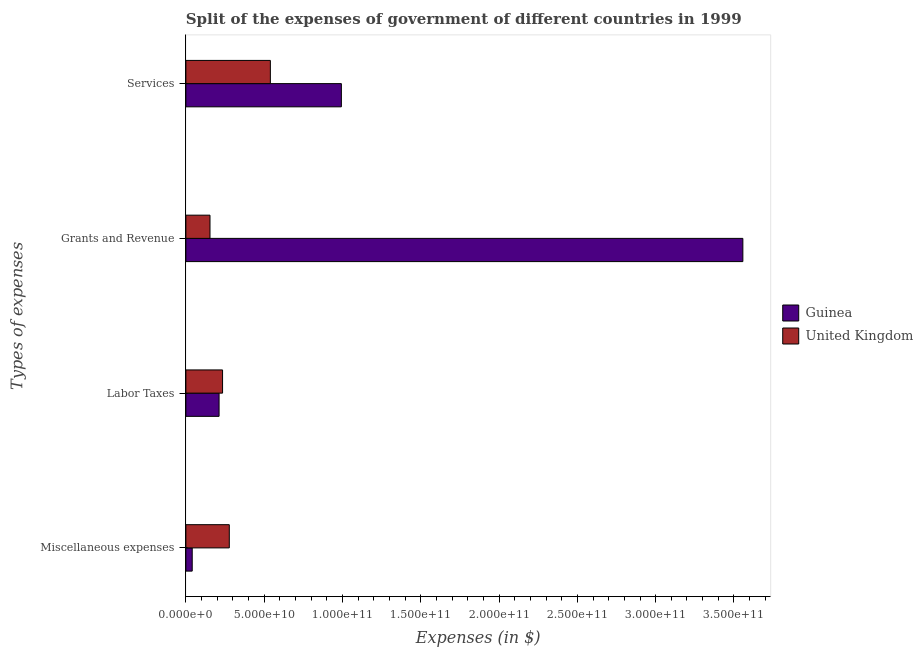How many different coloured bars are there?
Your answer should be very brief. 2. Are the number of bars on each tick of the Y-axis equal?
Your answer should be compact. Yes. How many bars are there on the 3rd tick from the top?
Give a very brief answer. 2. What is the label of the 3rd group of bars from the top?
Keep it short and to the point. Labor Taxes. What is the amount spent on services in United Kingdom?
Ensure brevity in your answer.  5.39e+1. Across all countries, what is the maximum amount spent on grants and revenue?
Keep it short and to the point. 3.56e+11. Across all countries, what is the minimum amount spent on labor taxes?
Your response must be concise. 2.12e+1. In which country was the amount spent on services maximum?
Provide a succinct answer. Guinea. What is the total amount spent on miscellaneous expenses in the graph?
Your response must be concise. 3.18e+1. What is the difference between the amount spent on services in United Kingdom and that in Guinea?
Your answer should be compact. -4.54e+1. What is the difference between the amount spent on labor taxes in United Kingdom and the amount spent on miscellaneous expenses in Guinea?
Offer a terse response. 1.94e+1. What is the average amount spent on miscellaneous expenses per country?
Provide a succinct answer. 1.59e+1. What is the difference between the amount spent on grants and revenue and amount spent on labor taxes in United Kingdom?
Offer a very short reply. -8.03e+09. What is the ratio of the amount spent on services in Guinea to that in United Kingdom?
Make the answer very short. 1.84. What is the difference between the highest and the second highest amount spent on grants and revenue?
Offer a terse response. 3.40e+11. What is the difference between the highest and the lowest amount spent on grants and revenue?
Ensure brevity in your answer.  3.40e+11. What does the 1st bar from the bottom in Grants and Revenue represents?
Give a very brief answer. Guinea. Is it the case that in every country, the sum of the amount spent on miscellaneous expenses and amount spent on labor taxes is greater than the amount spent on grants and revenue?
Your answer should be compact. No. How many bars are there?
Give a very brief answer. 8. What is the title of the graph?
Offer a very short reply. Split of the expenses of government of different countries in 1999. Does "Belgium" appear as one of the legend labels in the graph?
Your response must be concise. No. What is the label or title of the X-axis?
Keep it short and to the point. Expenses (in $). What is the label or title of the Y-axis?
Make the answer very short. Types of expenses. What is the Expenses (in $) in Guinea in Miscellaneous expenses?
Provide a short and direct response. 4.05e+09. What is the Expenses (in $) in United Kingdom in Miscellaneous expenses?
Make the answer very short. 2.77e+1. What is the Expenses (in $) of Guinea in Labor Taxes?
Offer a terse response. 2.12e+1. What is the Expenses (in $) of United Kingdom in Labor Taxes?
Ensure brevity in your answer.  2.34e+1. What is the Expenses (in $) in Guinea in Grants and Revenue?
Keep it short and to the point. 3.56e+11. What is the Expenses (in $) in United Kingdom in Grants and Revenue?
Your response must be concise. 1.54e+1. What is the Expenses (in $) in Guinea in Services?
Ensure brevity in your answer.  9.93e+1. What is the Expenses (in $) in United Kingdom in Services?
Ensure brevity in your answer.  5.39e+1. Across all Types of expenses, what is the maximum Expenses (in $) of Guinea?
Make the answer very short. 3.56e+11. Across all Types of expenses, what is the maximum Expenses (in $) of United Kingdom?
Ensure brevity in your answer.  5.39e+1. Across all Types of expenses, what is the minimum Expenses (in $) of Guinea?
Your response must be concise. 4.05e+09. Across all Types of expenses, what is the minimum Expenses (in $) in United Kingdom?
Offer a very short reply. 1.54e+1. What is the total Expenses (in $) in Guinea in the graph?
Provide a short and direct response. 4.80e+11. What is the total Expenses (in $) of United Kingdom in the graph?
Offer a very short reply. 1.21e+11. What is the difference between the Expenses (in $) of Guinea in Miscellaneous expenses and that in Labor Taxes?
Ensure brevity in your answer.  -1.72e+1. What is the difference between the Expenses (in $) of United Kingdom in Miscellaneous expenses and that in Labor Taxes?
Provide a succinct answer. 4.30e+09. What is the difference between the Expenses (in $) of Guinea in Miscellaneous expenses and that in Grants and Revenue?
Offer a terse response. -3.52e+11. What is the difference between the Expenses (in $) of United Kingdom in Miscellaneous expenses and that in Grants and Revenue?
Your answer should be compact. 1.23e+1. What is the difference between the Expenses (in $) in Guinea in Miscellaneous expenses and that in Services?
Make the answer very short. -9.52e+1. What is the difference between the Expenses (in $) of United Kingdom in Miscellaneous expenses and that in Services?
Your response must be concise. -2.62e+1. What is the difference between the Expenses (in $) of Guinea in Labor Taxes and that in Grants and Revenue?
Your answer should be very brief. -3.34e+11. What is the difference between the Expenses (in $) of United Kingdom in Labor Taxes and that in Grants and Revenue?
Keep it short and to the point. 8.03e+09. What is the difference between the Expenses (in $) of Guinea in Labor Taxes and that in Services?
Keep it short and to the point. -7.81e+1. What is the difference between the Expenses (in $) in United Kingdom in Labor Taxes and that in Services?
Your answer should be compact. -3.05e+1. What is the difference between the Expenses (in $) in Guinea in Grants and Revenue and that in Services?
Ensure brevity in your answer.  2.56e+11. What is the difference between the Expenses (in $) of United Kingdom in Grants and Revenue and that in Services?
Your answer should be compact. -3.85e+1. What is the difference between the Expenses (in $) in Guinea in Miscellaneous expenses and the Expenses (in $) in United Kingdom in Labor Taxes?
Offer a terse response. -1.94e+1. What is the difference between the Expenses (in $) in Guinea in Miscellaneous expenses and the Expenses (in $) in United Kingdom in Grants and Revenue?
Provide a short and direct response. -1.14e+1. What is the difference between the Expenses (in $) of Guinea in Miscellaneous expenses and the Expenses (in $) of United Kingdom in Services?
Provide a succinct answer. -4.99e+1. What is the difference between the Expenses (in $) of Guinea in Labor Taxes and the Expenses (in $) of United Kingdom in Grants and Revenue?
Give a very brief answer. 5.80e+09. What is the difference between the Expenses (in $) in Guinea in Labor Taxes and the Expenses (in $) in United Kingdom in Services?
Keep it short and to the point. -3.27e+1. What is the difference between the Expenses (in $) of Guinea in Grants and Revenue and the Expenses (in $) of United Kingdom in Services?
Your answer should be very brief. 3.02e+11. What is the average Expenses (in $) in Guinea per Types of expenses?
Provide a short and direct response. 1.20e+11. What is the average Expenses (in $) of United Kingdom per Types of expenses?
Your response must be concise. 3.01e+1. What is the difference between the Expenses (in $) of Guinea and Expenses (in $) of United Kingdom in Miscellaneous expenses?
Give a very brief answer. -2.37e+1. What is the difference between the Expenses (in $) in Guinea and Expenses (in $) in United Kingdom in Labor Taxes?
Your answer should be very brief. -2.23e+09. What is the difference between the Expenses (in $) in Guinea and Expenses (in $) in United Kingdom in Grants and Revenue?
Your response must be concise. 3.40e+11. What is the difference between the Expenses (in $) in Guinea and Expenses (in $) in United Kingdom in Services?
Ensure brevity in your answer.  4.54e+1. What is the ratio of the Expenses (in $) in Guinea in Miscellaneous expenses to that in Labor Taxes?
Make the answer very short. 0.19. What is the ratio of the Expenses (in $) of United Kingdom in Miscellaneous expenses to that in Labor Taxes?
Your answer should be compact. 1.18. What is the ratio of the Expenses (in $) of Guinea in Miscellaneous expenses to that in Grants and Revenue?
Offer a terse response. 0.01. What is the ratio of the Expenses (in $) of United Kingdom in Miscellaneous expenses to that in Grants and Revenue?
Keep it short and to the point. 1.8. What is the ratio of the Expenses (in $) of Guinea in Miscellaneous expenses to that in Services?
Make the answer very short. 0.04. What is the ratio of the Expenses (in $) of United Kingdom in Miscellaneous expenses to that in Services?
Your answer should be compact. 0.51. What is the ratio of the Expenses (in $) of Guinea in Labor Taxes to that in Grants and Revenue?
Offer a very short reply. 0.06. What is the ratio of the Expenses (in $) in United Kingdom in Labor Taxes to that in Grants and Revenue?
Offer a terse response. 1.52. What is the ratio of the Expenses (in $) of Guinea in Labor Taxes to that in Services?
Offer a terse response. 0.21. What is the ratio of the Expenses (in $) of United Kingdom in Labor Taxes to that in Services?
Ensure brevity in your answer.  0.43. What is the ratio of the Expenses (in $) in Guinea in Grants and Revenue to that in Services?
Make the answer very short. 3.58. What is the ratio of the Expenses (in $) in United Kingdom in Grants and Revenue to that in Services?
Make the answer very short. 0.29. What is the difference between the highest and the second highest Expenses (in $) in Guinea?
Provide a succinct answer. 2.56e+11. What is the difference between the highest and the second highest Expenses (in $) of United Kingdom?
Provide a succinct answer. 2.62e+1. What is the difference between the highest and the lowest Expenses (in $) in Guinea?
Offer a very short reply. 3.52e+11. What is the difference between the highest and the lowest Expenses (in $) in United Kingdom?
Keep it short and to the point. 3.85e+1. 